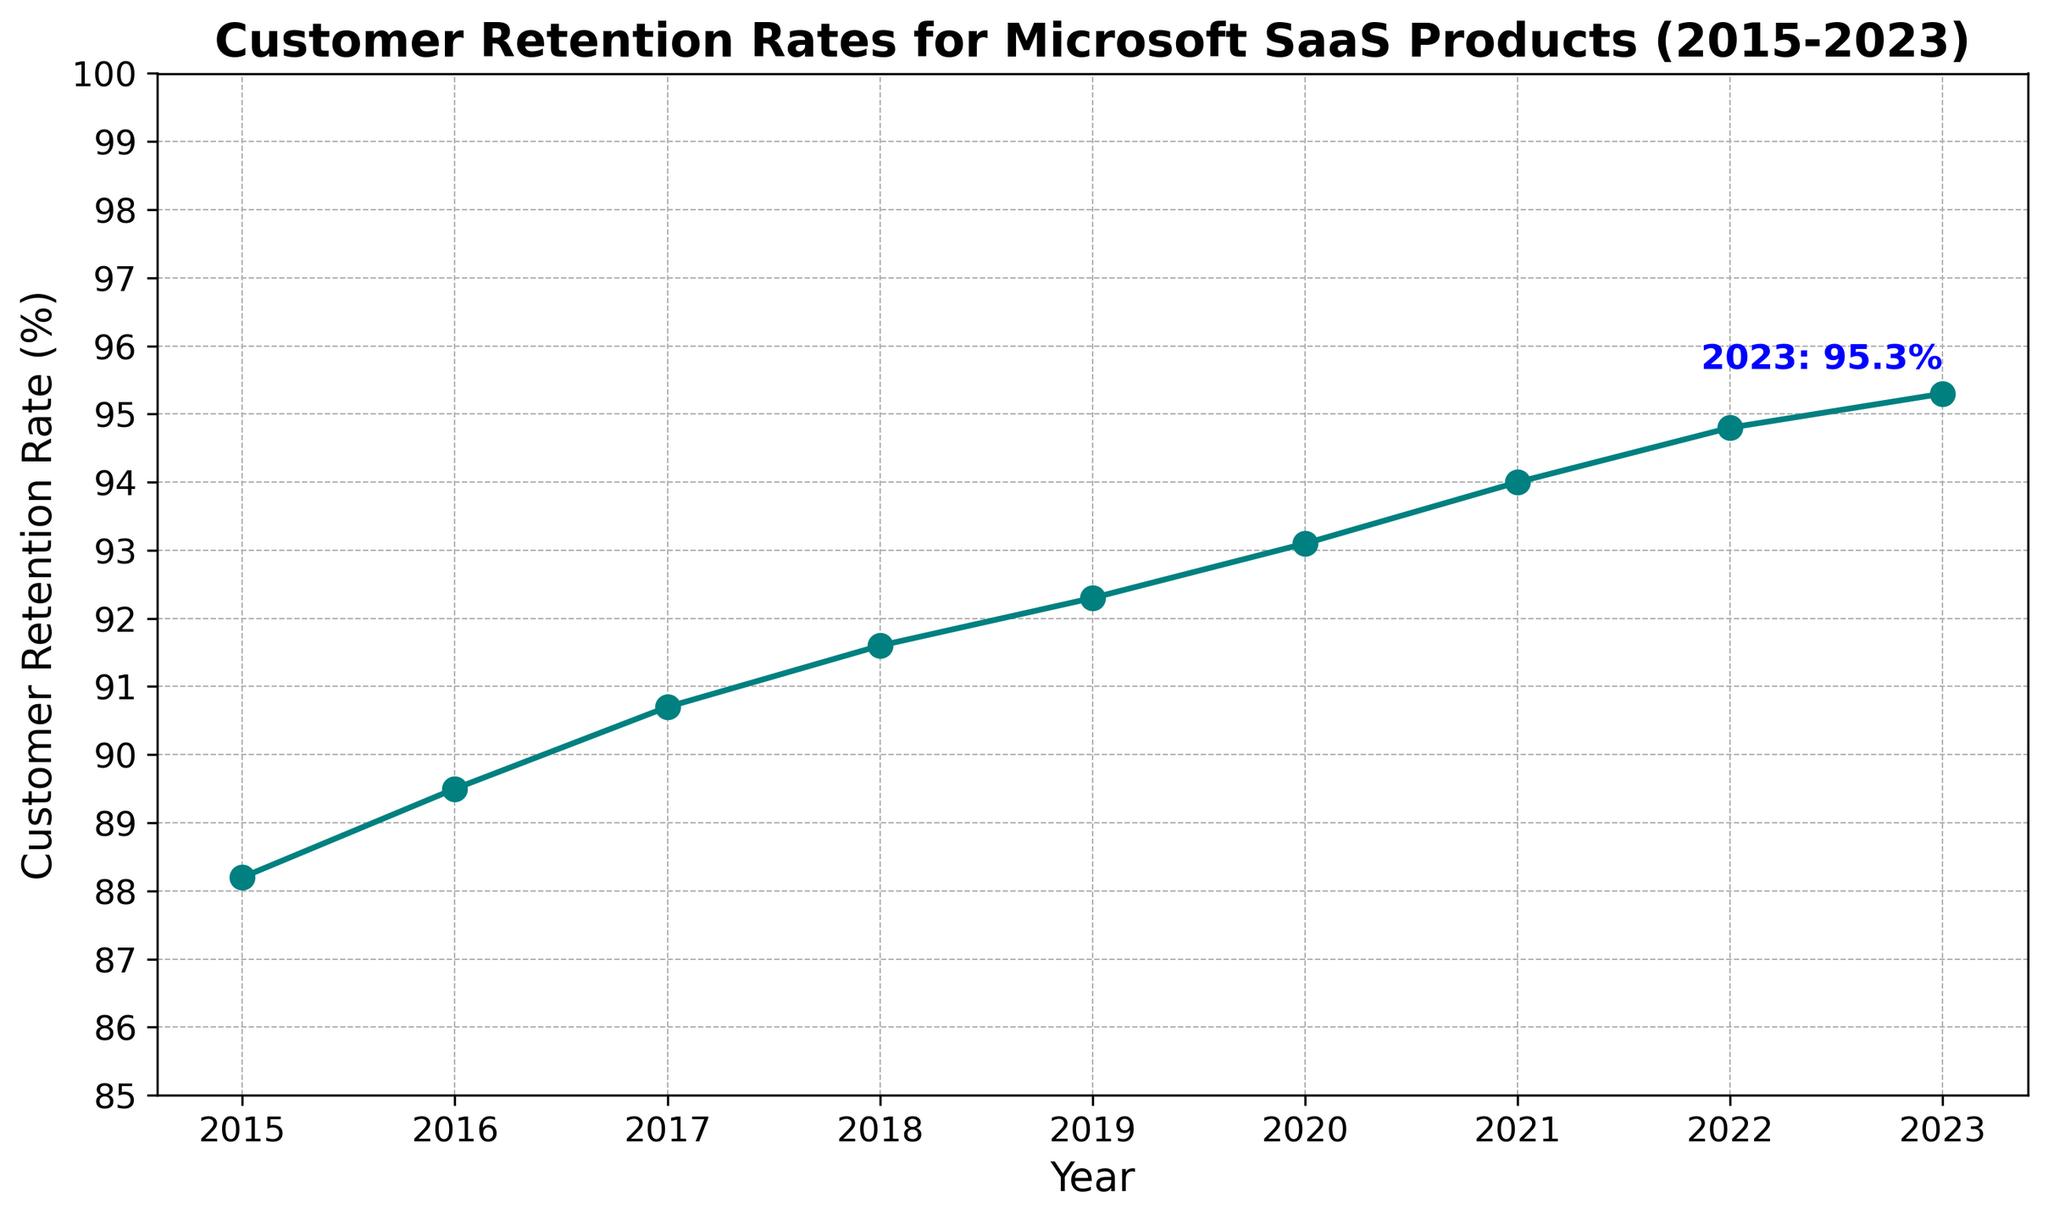what is the overall trend in customer retention rates from 2015 to 2023? The line chart shows an upward trajectory from 2015 to 2023, indicating a consistent increase in customer retention rates each year.
Answer: Upward trend how much did the customer retention rate increase from 2015 to 2023? Subtract the 2015 retention rate (88.2%) from the 2023 retention rate (95.3%), which results in an increase of 7.1%.
Answer: 7.1% in which year was there the highest gain in customer retention rate compared to the previous year? Compare the year-over-year differences: 
2015-2016: 1.3% 
2016-2017: 1.2% 
2017-2018: 0.9% 
2018-2019: 0.7% 
2019-2020: 0.8% 
2020-2021: 0.9% 
2021-2022: 0.8% 
2022-2023: 0.5% 
The highest is from 2015 to 2016 with a gain of 1.3%.
Answer: 2015 to 2016 what is the average customer retention rate from 2015 to 2023? Calculate the average by summing the retention rates and dividing by the number of years.
(88.2 + 89.5 + 90.7 + 91.6 + 92.3 + 93.1 + 94.0 + 94.8 + 95.3) / 9 = 92.7%
Answer: 92.7% which year had the lowest customer retention rate? The chart shows that the lowest rate is in 2015 with 88.2%.
Answer: 2015 how does the retention rate in 2020 compare to 2022? The chart indicates that the retention rate in 2020 is 93.1%, and in 2022, it is 94.8%. The retention rate in 2022 is higher than in 2020.
Answer: 2022 > 2020 by how much did the customer retention rate increase from 2019 to 2020? Subtract the 2019 retention rate (92.3%) from the 2020 retention rate (93.1%) which gives an increase of 0.8%.
Answer: 0.8% how many data points are there in the chart? The plotted data ranges from 2015 to 2023 inclusive, giving 9 data points.
Answer: 9 what is the overall percentage increase in customer retention rate from the start to the end of the period? Calculate by dividing the increase from 2015 to 2023 by the 2015 value and multiplying by 100:
(95.3 - 88.2) / 88.2 * 100 = 8.05%
Answer: 8.05% 